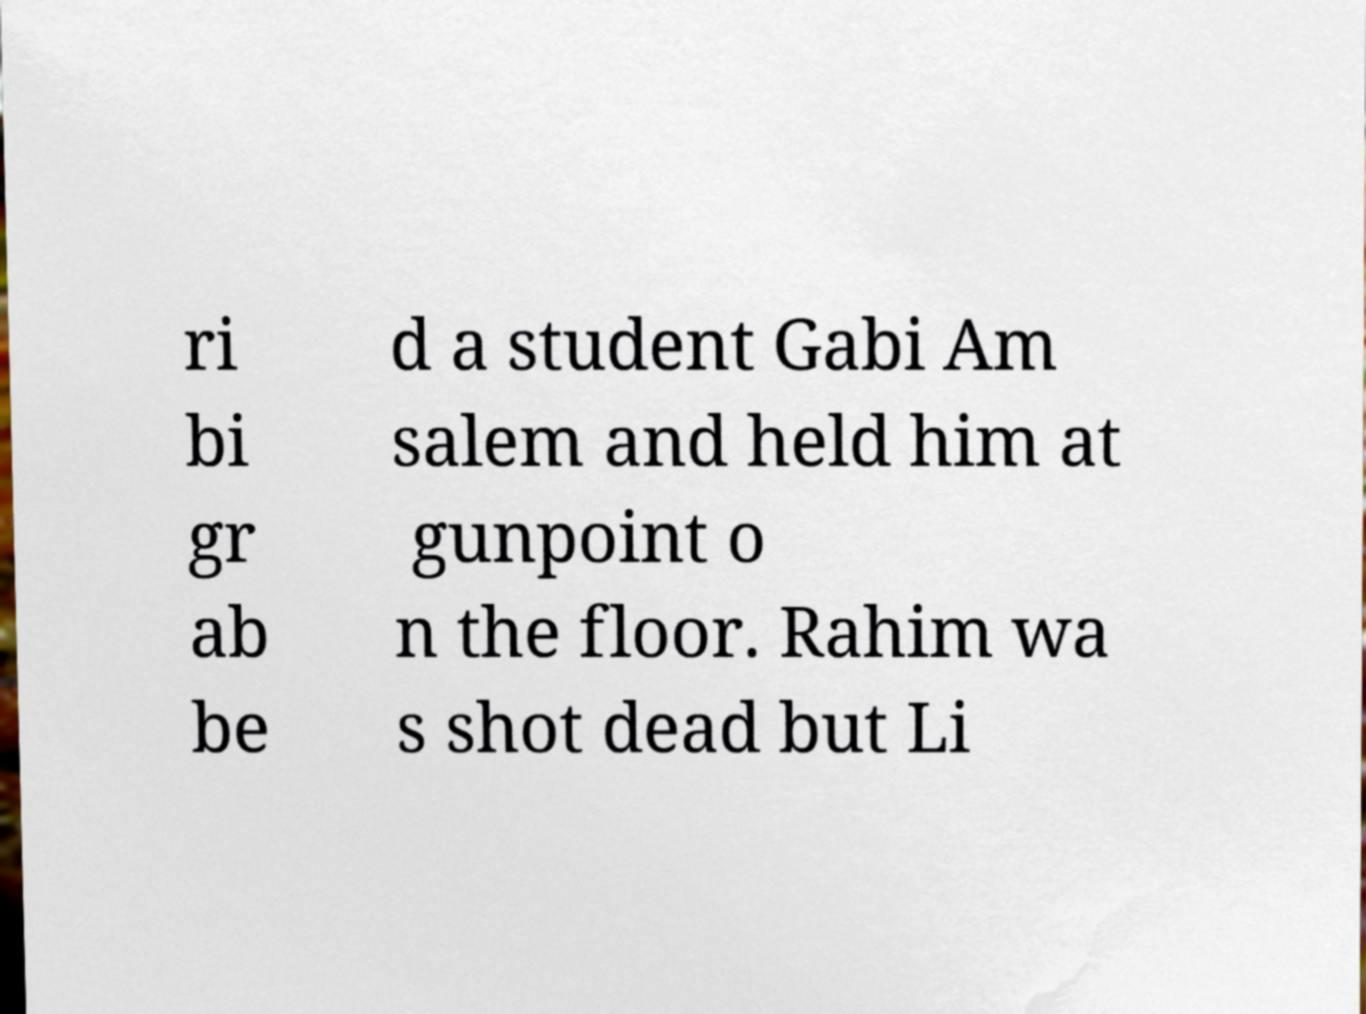I need the written content from this picture converted into text. Can you do that? ri bi gr ab be d a student Gabi Am salem and held him at gunpoint o n the floor. Rahim wa s shot dead but Li 